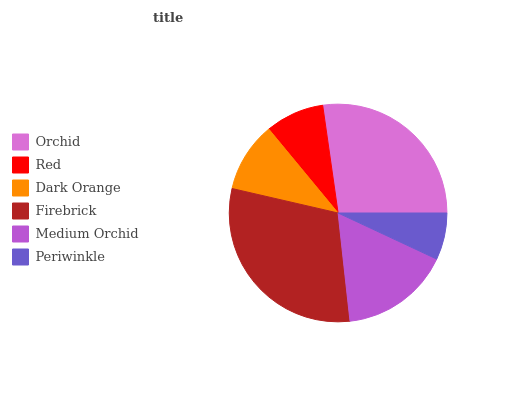Is Periwinkle the minimum?
Answer yes or no. Yes. Is Firebrick the maximum?
Answer yes or no. Yes. Is Red the minimum?
Answer yes or no. No. Is Red the maximum?
Answer yes or no. No. Is Orchid greater than Red?
Answer yes or no. Yes. Is Red less than Orchid?
Answer yes or no. Yes. Is Red greater than Orchid?
Answer yes or no. No. Is Orchid less than Red?
Answer yes or no. No. Is Medium Orchid the high median?
Answer yes or no. Yes. Is Dark Orange the low median?
Answer yes or no. Yes. Is Red the high median?
Answer yes or no. No. Is Periwinkle the low median?
Answer yes or no. No. 